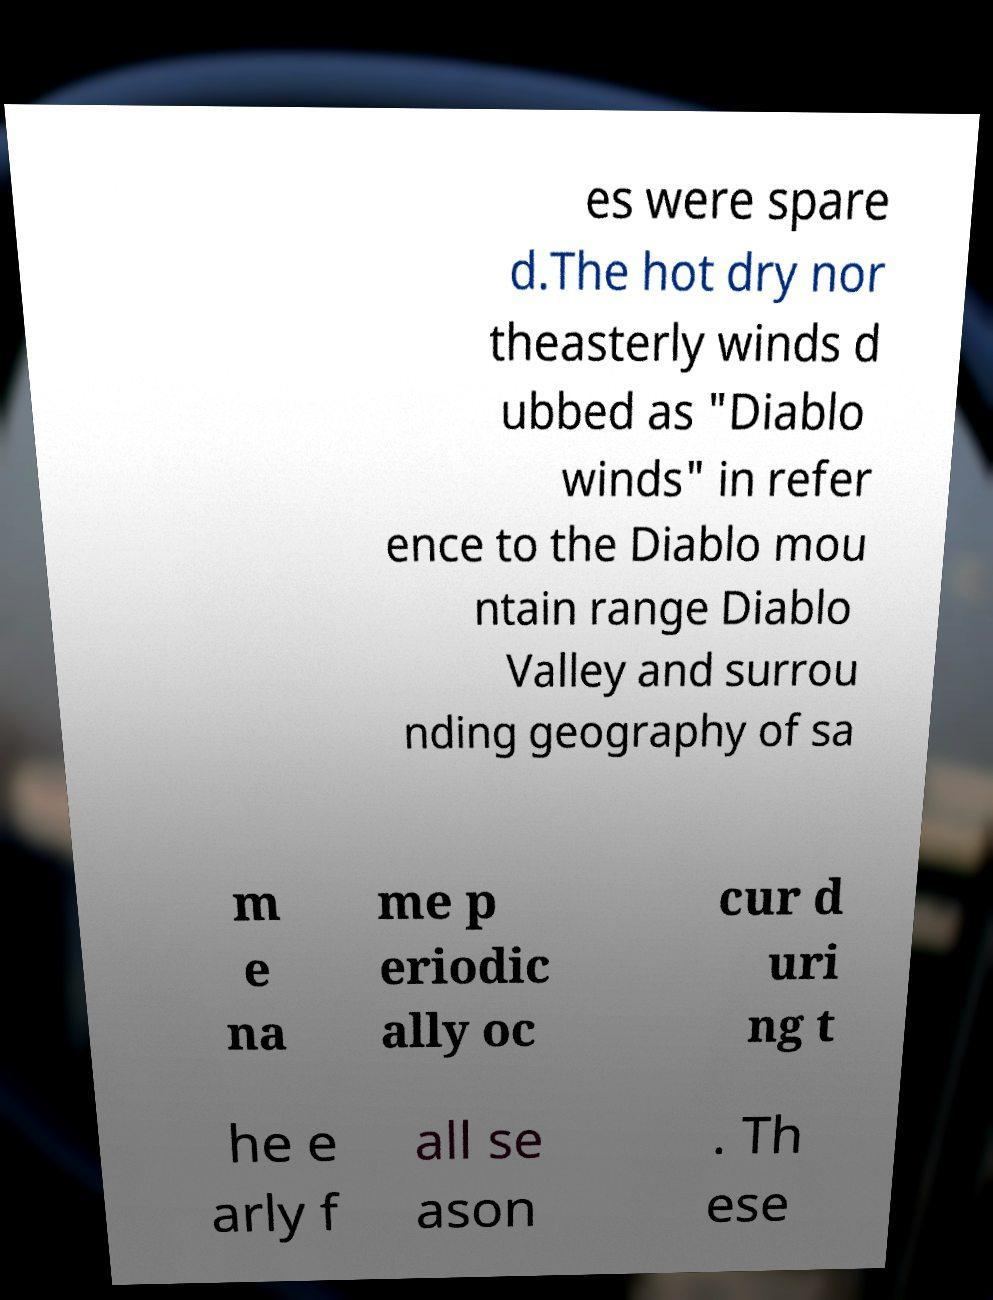There's text embedded in this image that I need extracted. Can you transcribe it verbatim? es were spare d.The hot dry nor theasterly winds d ubbed as "Diablo winds" in refer ence to the Diablo mou ntain range Diablo Valley and surrou nding geography of sa m e na me p eriodic ally oc cur d uri ng t he e arly f all se ason . Th ese 